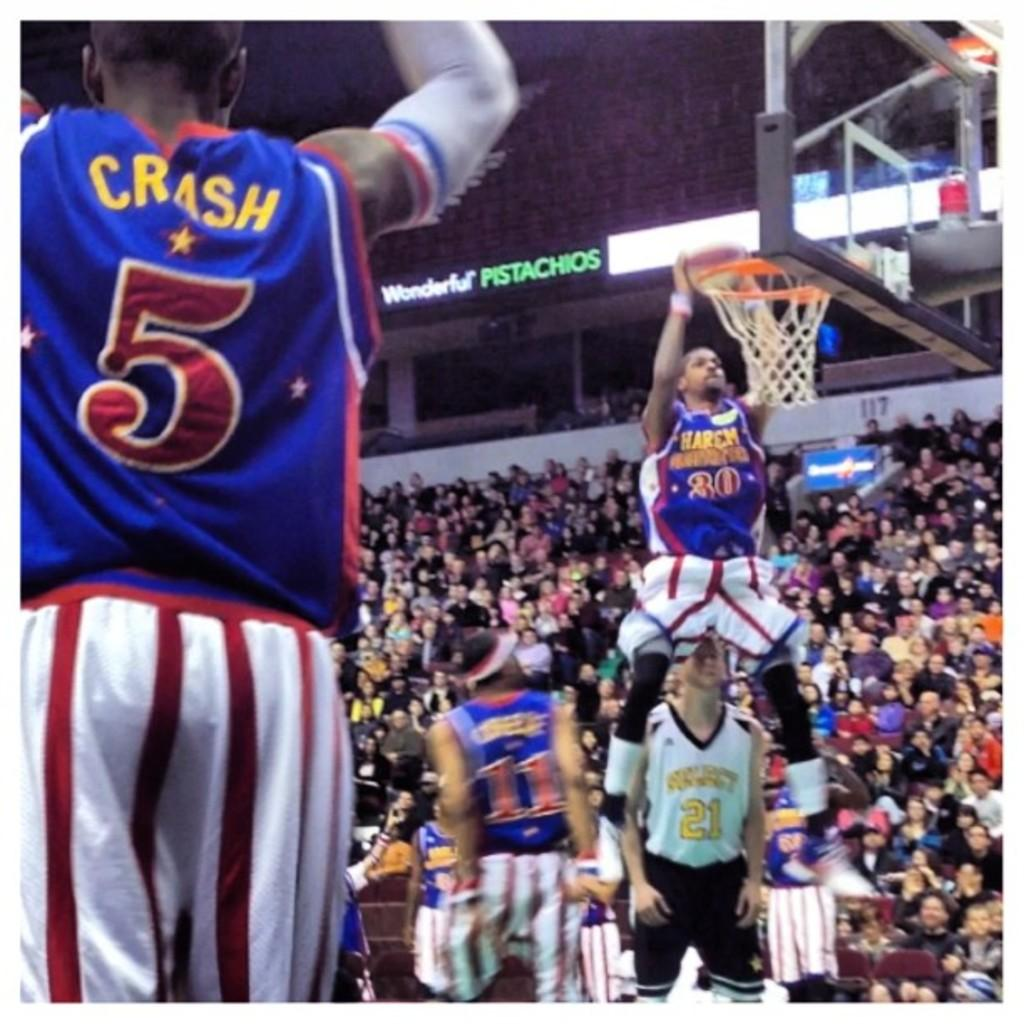<image>
Render a clear and concise summary of the photo. Crash, who wears jersey number 5, looks on as a teammate makes a basket. 